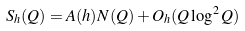Convert formula to latex. <formula><loc_0><loc_0><loc_500><loc_500>S _ { h } ( Q ) = A ( h ) N ( Q ) + O _ { h } ( Q \log ^ { 2 } Q )</formula> 